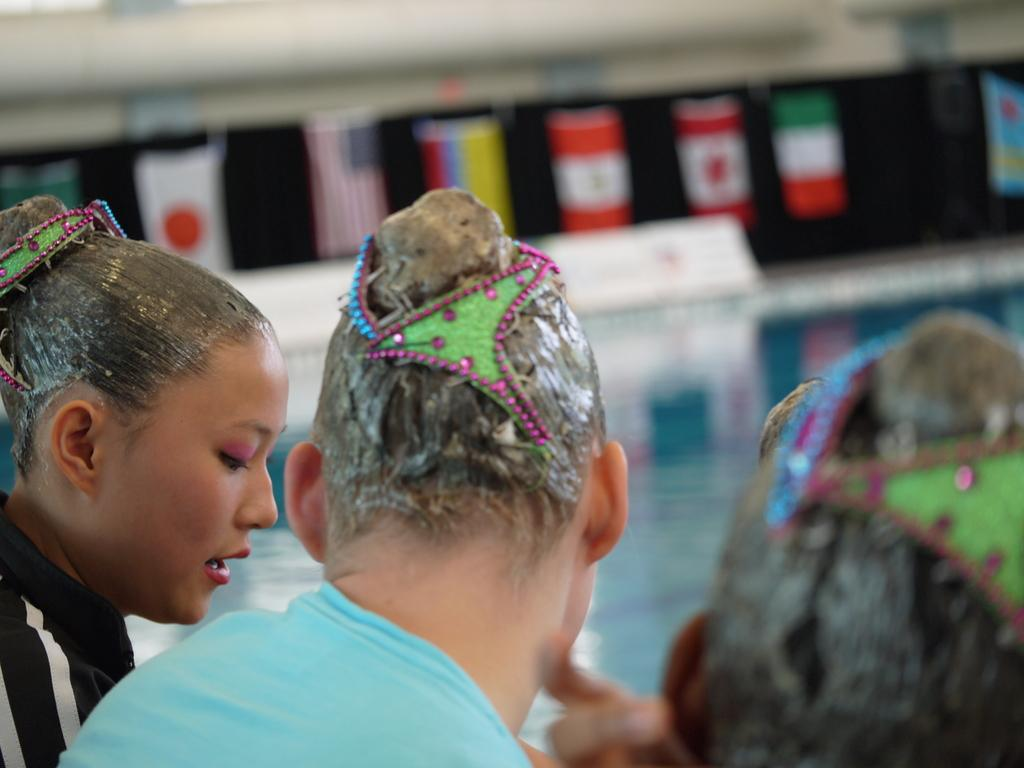How many people are sitting in the image? There are three people sitting in the image. What is one of the people doing in the image? One woman is talking in the image. Can you describe the background of the image? The background is blurry. What else can be seen in the background of the image? There are flags visible in the background. What type of ink is being used by the woman in the image? There is no ink present in the image, as the woman is talking, not writing or drawing. 